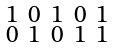<formula> <loc_0><loc_0><loc_500><loc_500>\begin{smallmatrix} 1 & 0 & 1 & 0 & 1 \\ 0 & 1 & 0 & 1 & 1 \end{smallmatrix}</formula> 